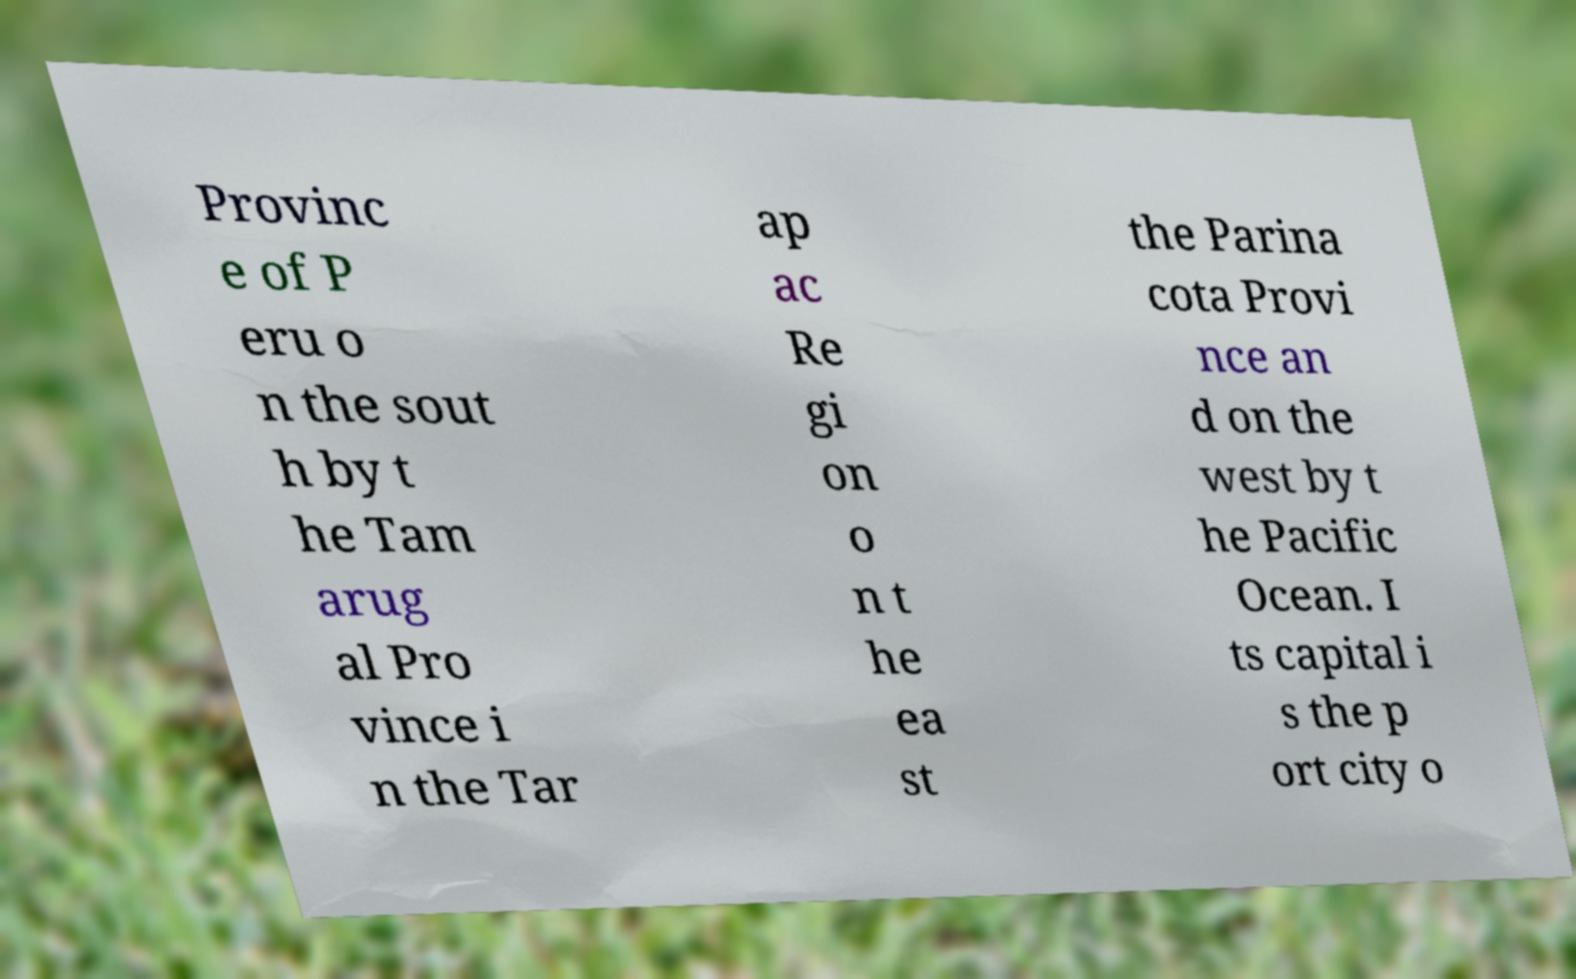For documentation purposes, I need the text within this image transcribed. Could you provide that? Provinc e of P eru o n the sout h by t he Tam arug al Pro vince i n the Tar ap ac Re gi on o n t he ea st the Parina cota Provi nce an d on the west by t he Pacific Ocean. I ts capital i s the p ort city o 